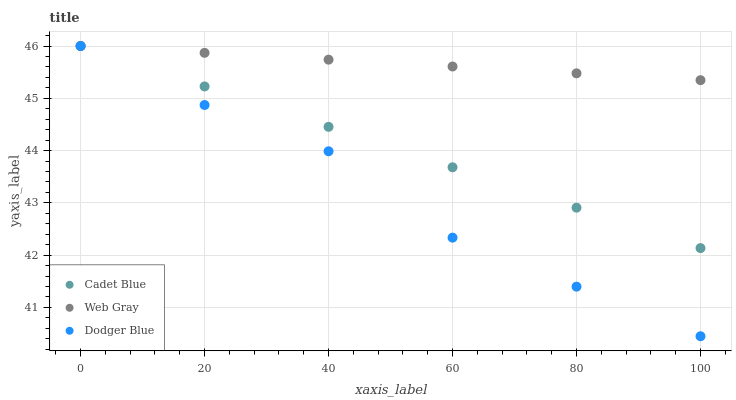Does Dodger Blue have the minimum area under the curve?
Answer yes or no. Yes. Does Web Gray have the maximum area under the curve?
Answer yes or no. Yes. Does Cadet Blue have the minimum area under the curve?
Answer yes or no. No. Does Cadet Blue have the maximum area under the curve?
Answer yes or no. No. Is Web Gray the smoothest?
Answer yes or no. Yes. Is Dodger Blue the roughest?
Answer yes or no. Yes. Is Cadet Blue the smoothest?
Answer yes or no. No. Is Cadet Blue the roughest?
Answer yes or no. No. Does Dodger Blue have the lowest value?
Answer yes or no. Yes. Does Cadet Blue have the lowest value?
Answer yes or no. No. Does Web Gray have the highest value?
Answer yes or no. Yes. Does Web Gray intersect Cadet Blue?
Answer yes or no. Yes. Is Web Gray less than Cadet Blue?
Answer yes or no. No. Is Web Gray greater than Cadet Blue?
Answer yes or no. No. 